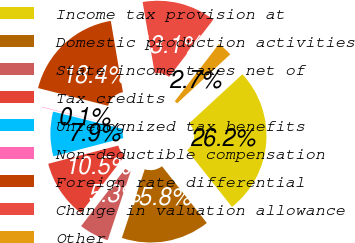Convert chart to OTSL. <chart><loc_0><loc_0><loc_500><loc_500><pie_chart><fcel>Income tax provision at<fcel>Domestic production activities<fcel>State income taxes net of<fcel>Tax credits<fcel>Unrecognized tax benefits<fcel>Non-deductible compensation<fcel>Foreign rate differential<fcel>Change in valuation allowance<fcel>Other<nl><fcel>26.21%<fcel>15.76%<fcel>5.3%<fcel>10.53%<fcel>7.92%<fcel>0.07%<fcel>18.37%<fcel>13.14%<fcel>2.69%<nl></chart> 